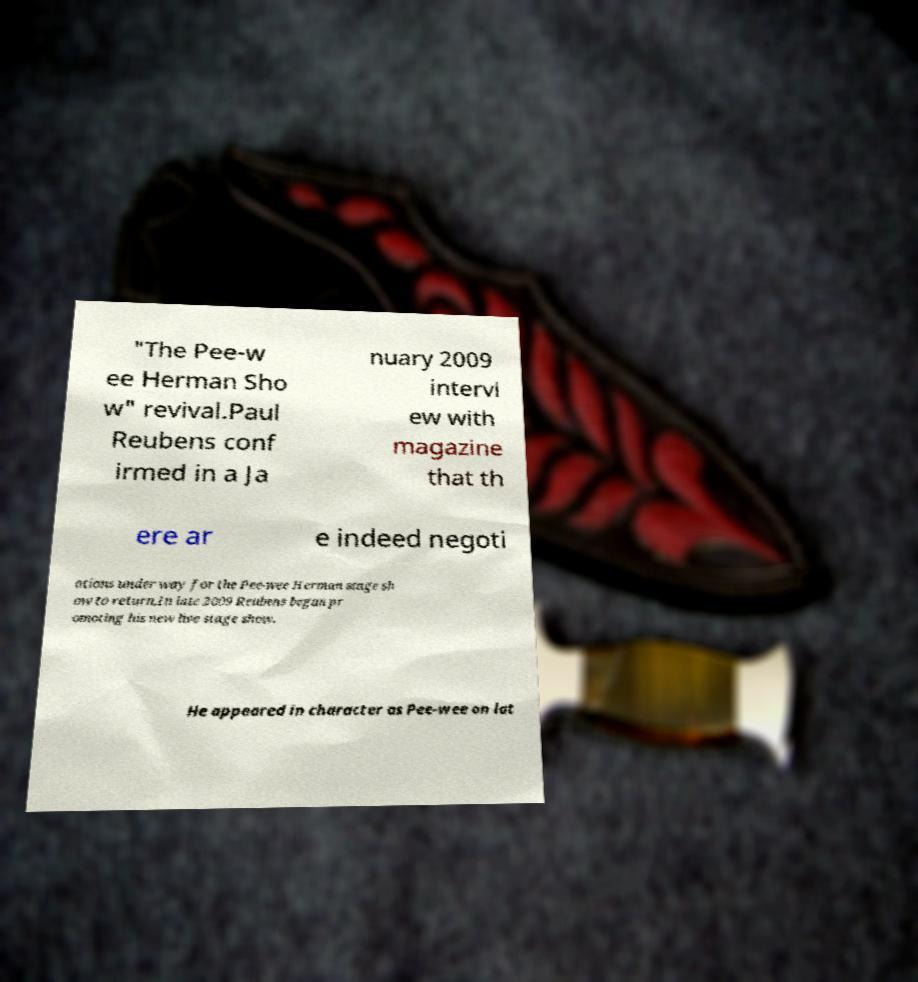Please identify and transcribe the text found in this image. "The Pee-w ee Herman Sho w" revival.Paul Reubens conf irmed in a Ja nuary 2009 intervi ew with magazine that th ere ar e indeed negoti ations under way for the Pee-wee Herman stage sh ow to return.In late 2009 Reubens began pr omoting his new live stage show. He appeared in character as Pee-wee on lat 